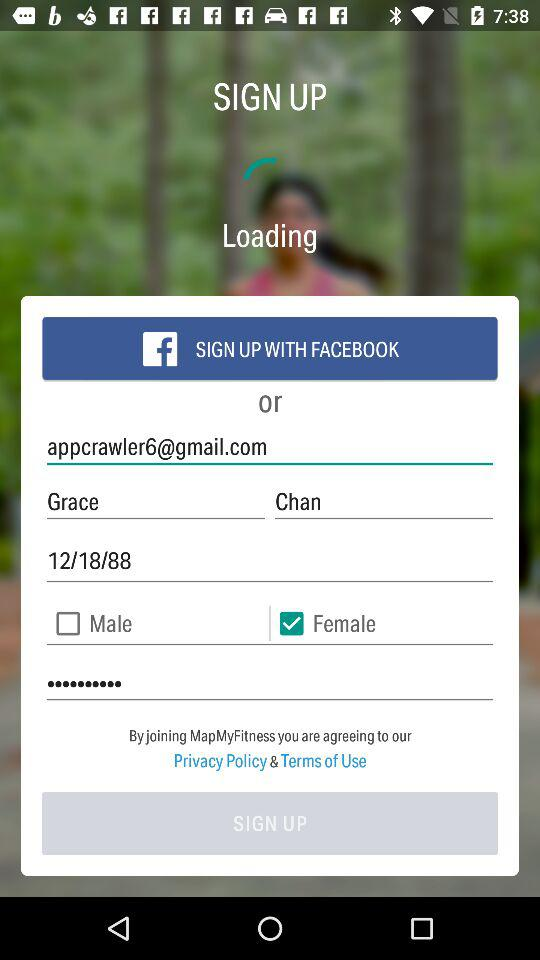By what app can we sign up? You can sign up through "FACEBOOK". 